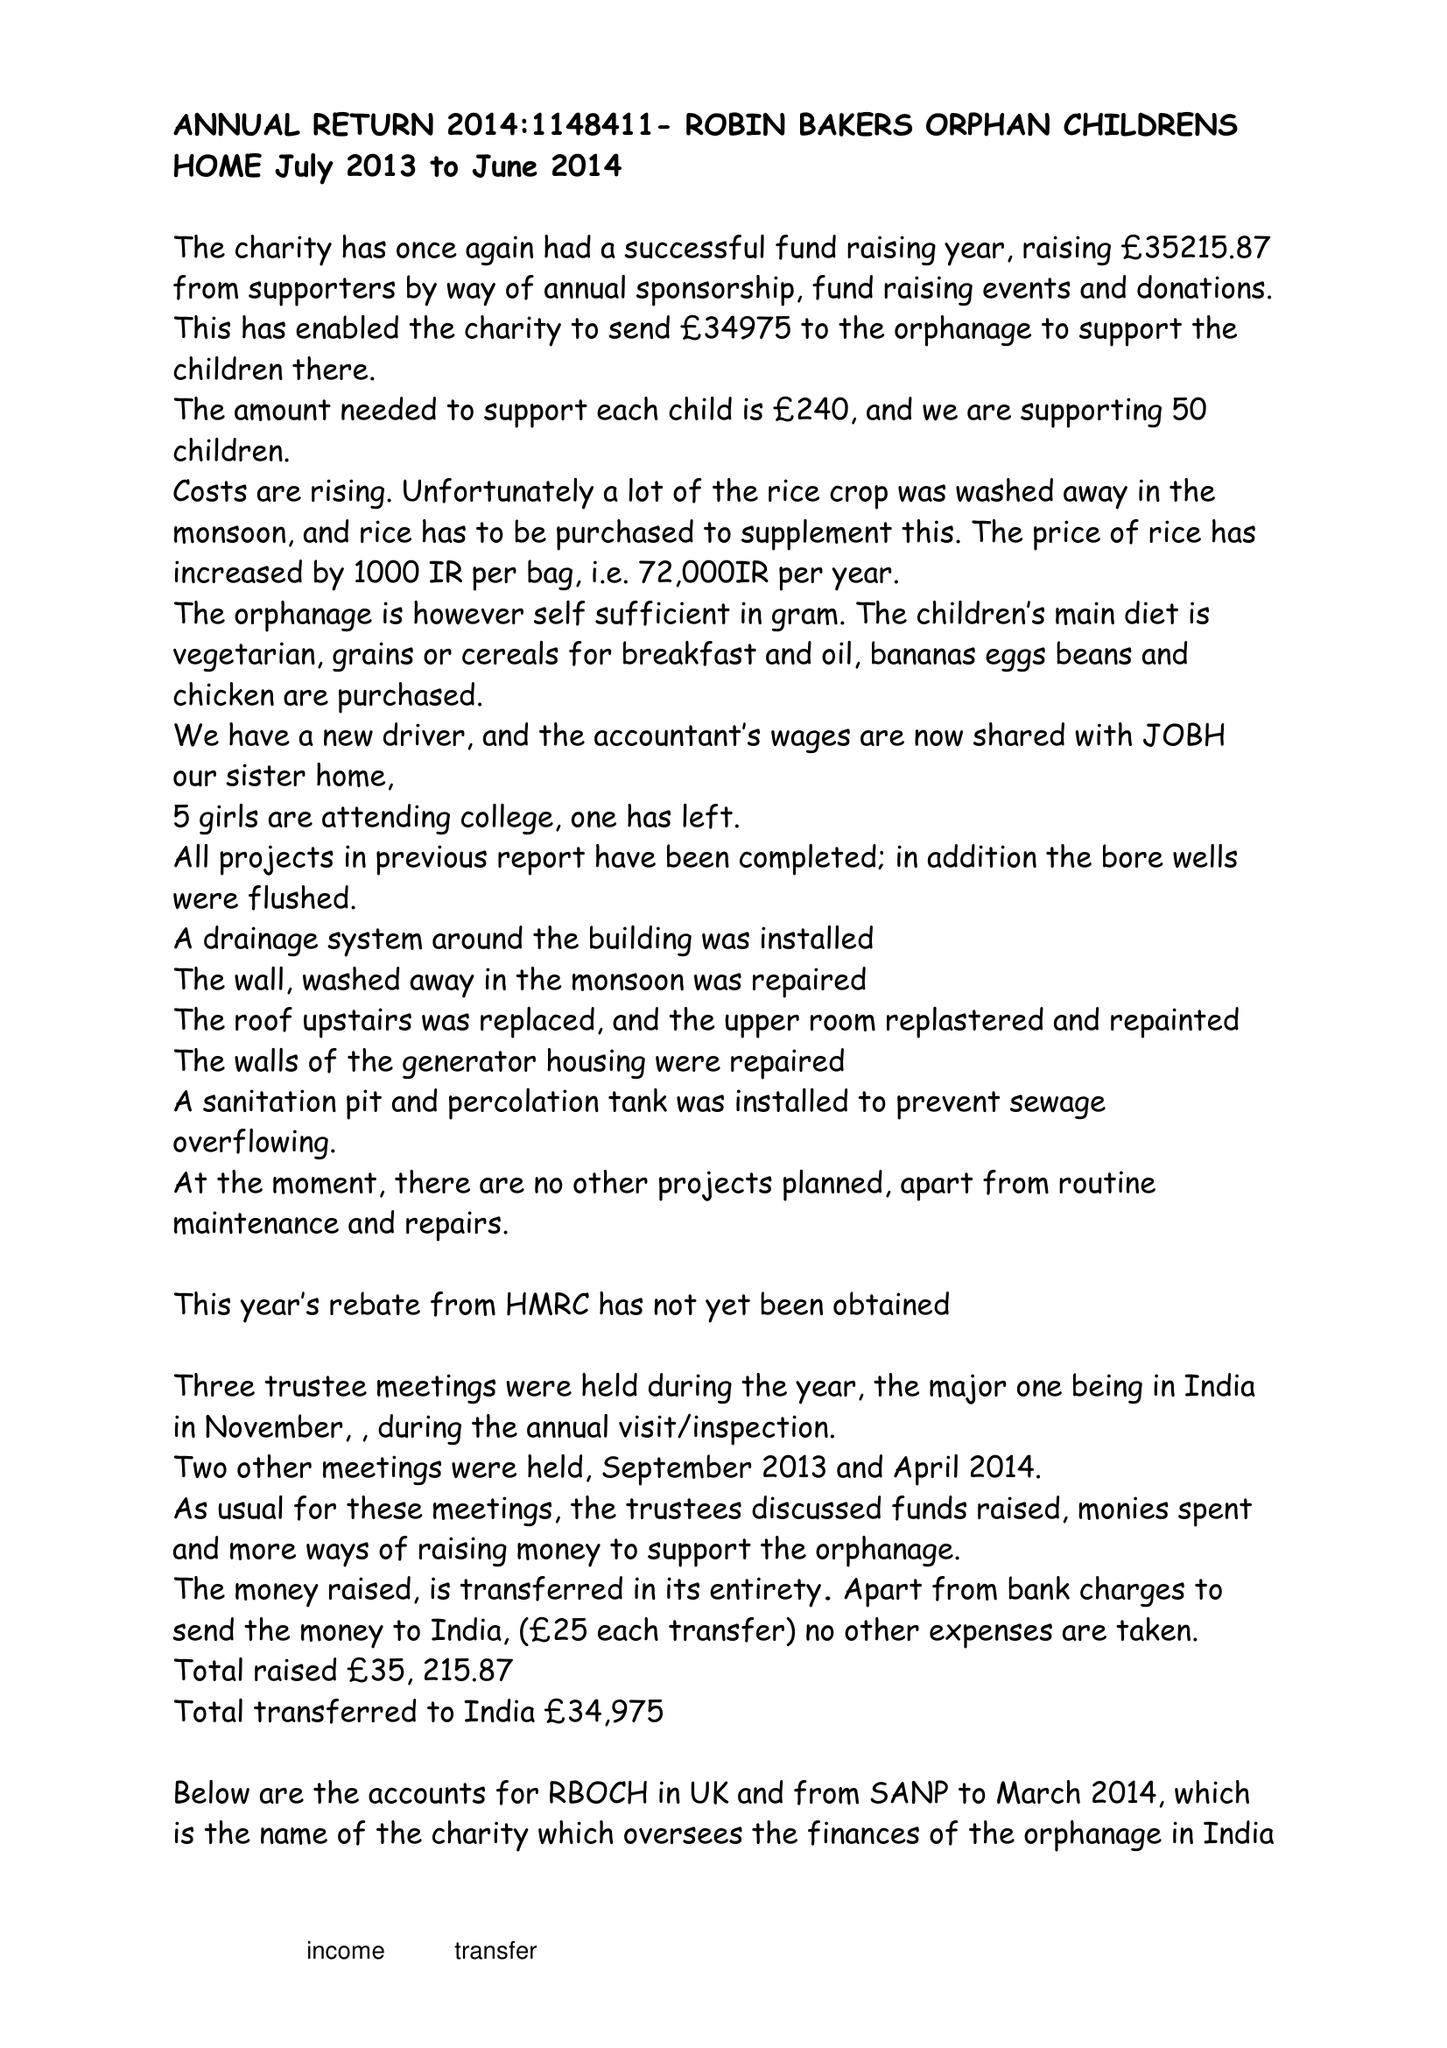What is the value for the report_date?
Answer the question using a single word or phrase. 2014-06-30 